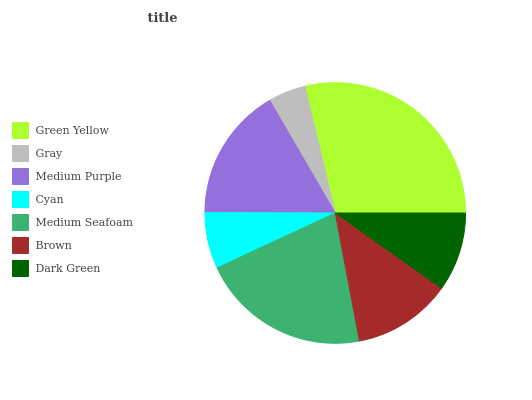Is Gray the minimum?
Answer yes or no. Yes. Is Green Yellow the maximum?
Answer yes or no. Yes. Is Medium Purple the minimum?
Answer yes or no. No. Is Medium Purple the maximum?
Answer yes or no. No. Is Medium Purple greater than Gray?
Answer yes or no. Yes. Is Gray less than Medium Purple?
Answer yes or no. Yes. Is Gray greater than Medium Purple?
Answer yes or no. No. Is Medium Purple less than Gray?
Answer yes or no. No. Is Brown the high median?
Answer yes or no. Yes. Is Brown the low median?
Answer yes or no. Yes. Is Gray the high median?
Answer yes or no. No. Is Medium Purple the low median?
Answer yes or no. No. 